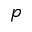<formula> <loc_0><loc_0><loc_500><loc_500>p</formula> 